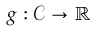Convert formula to latex. <formula><loc_0><loc_0><loc_500><loc_500>g \colon { \mathcal { C } } \to \mathbb { R }</formula> 